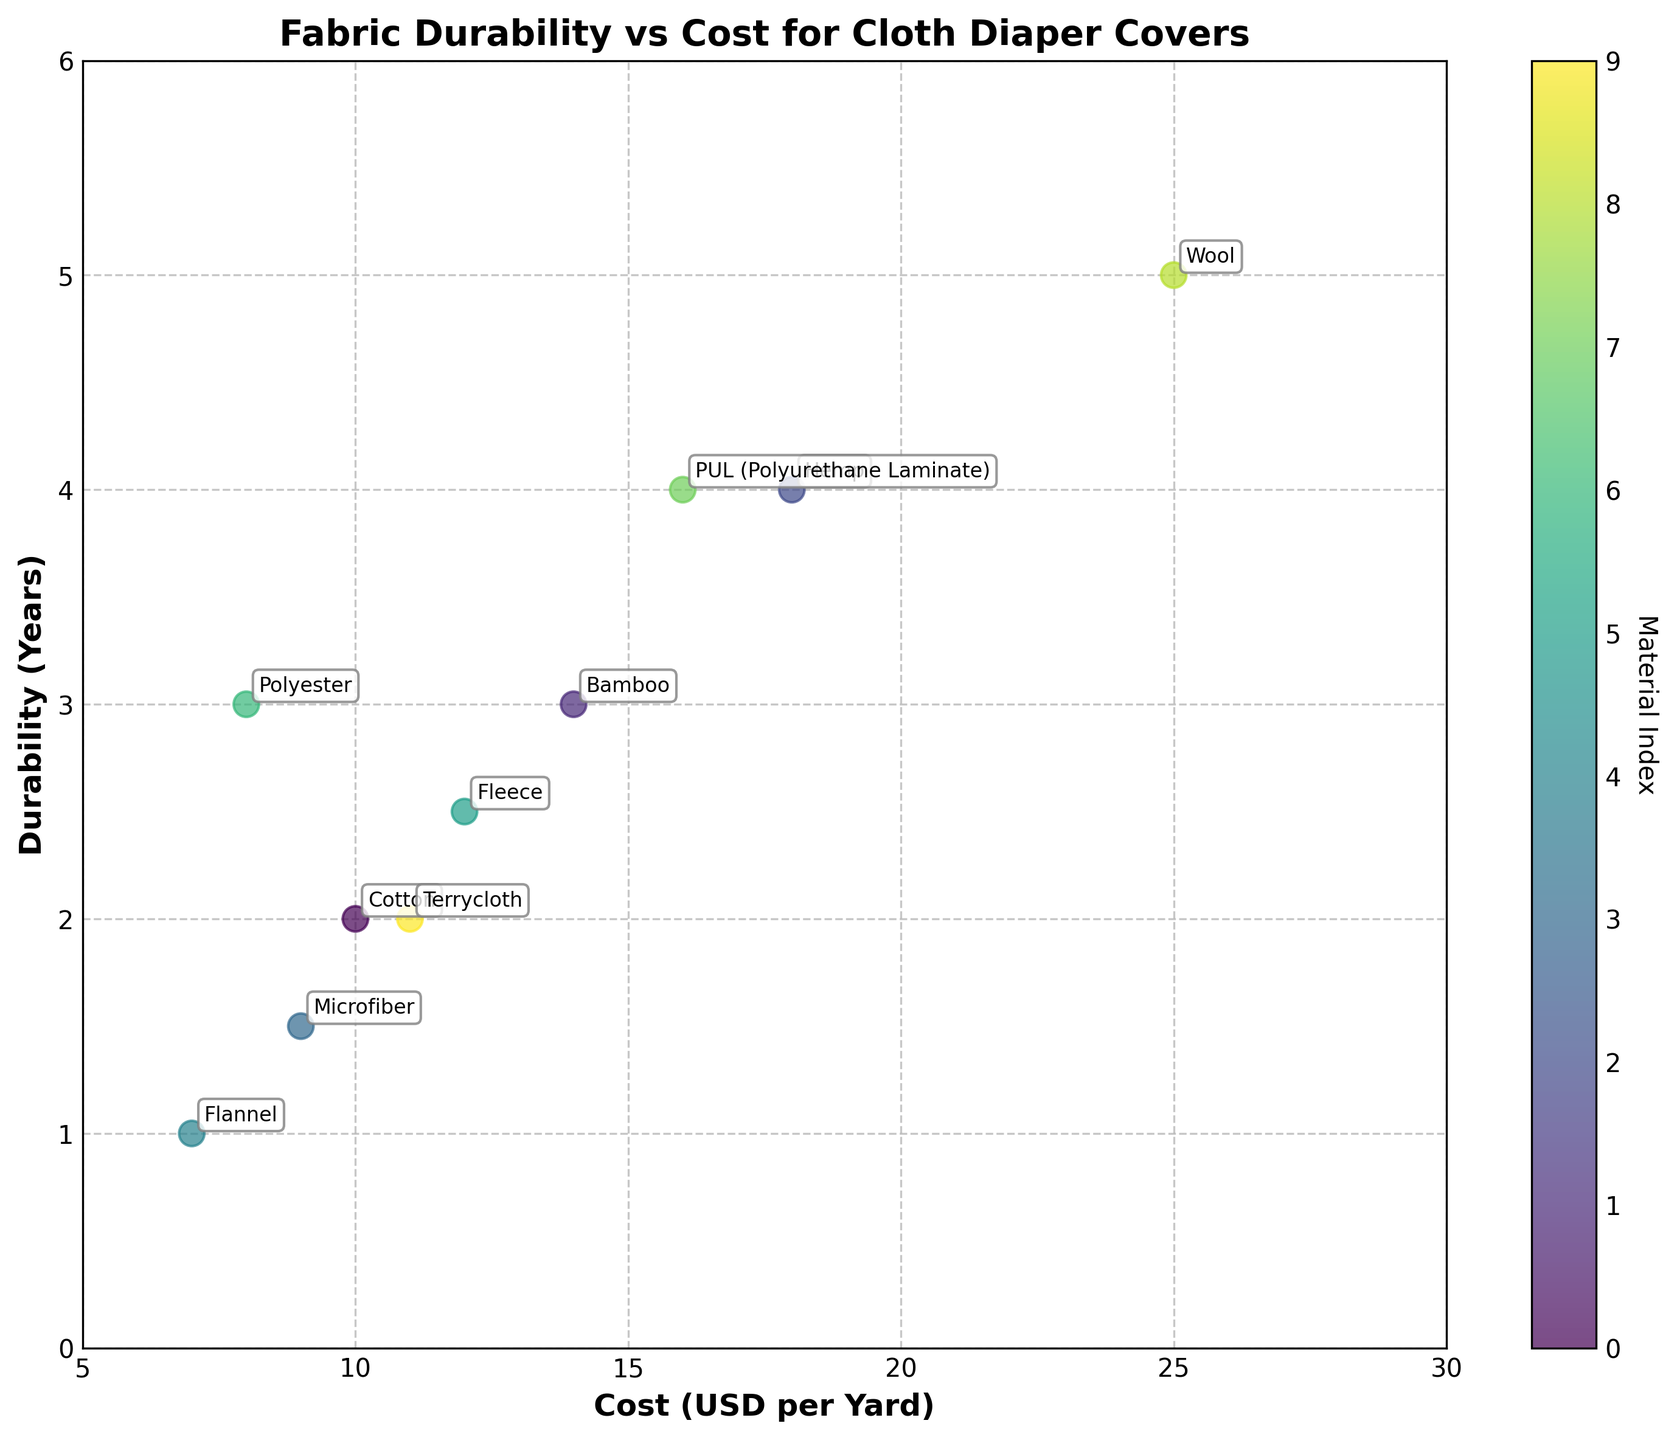What is the title of the plot? The title of the plot is located at the top center of the figure and provides a brief description of what the plot represents.
Answer: Fabric Durability vs Cost for Cloth Diaper Covers Which material has the highest durability? To find the material with the highest durability, look for the data point that is positioned the highest on the y-axis labeled "Durability (Years)".
Answer: Wool Which material has the lowest cost? To find the material with the lowest cost, look for the data point that is positioned the furthest to the left on the x-axis labeled "Cost (USD per Yard)".
Answer: Flannel Which two materials are closest to each other in terms of both cost and durability? To determine this, look for two data points that are positioned near each other on the plot, considering both x (cost) and y (durability) coordinates.
Answer: Cotton and Fleece Which material has the greatest difference between cost and durability? Calculate the difference for each material by subtracting the durability value from the cost value. Identify which material has the highest positive or negative difference.
Answer: Wool How many materials have a durability of 3 years or more? Count the number of data points that are positioned at or above the y-axis value of 3 on the plot.
Answer: 4 What is the cost range of the materials used in this plot? Determine the minimum and maximum values on the x-axis labeled "Cost (USD per Yard)" by looking at the furthest left and right data points.
Answer: $7 to $25 Is there a general trend between cost and durability? Observe the overall pattern of the data points on the plot. If there is a visible trend (e.g., as cost increases, so does durability), state that.
Answer: Yes, higher cost generally relates to higher durability Which material appears more durable than it is costly? Find materials where the durability value on the y-axis is greater than their cost value on the x-axis.
Answer: Wool Is there any material that has a higher cost but lower durability compare to others? Identify any data points that are positioned high on the x-axis (cost) but low on the y-axis (durability).
Answer: No 